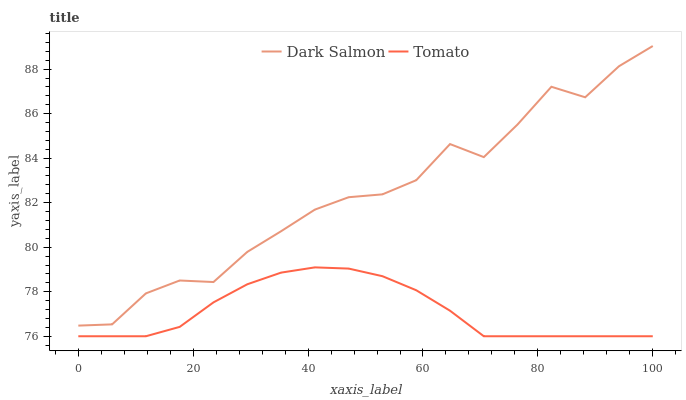Does Tomato have the minimum area under the curve?
Answer yes or no. Yes. Does Dark Salmon have the maximum area under the curve?
Answer yes or no. Yes. Does Dark Salmon have the minimum area under the curve?
Answer yes or no. No. Is Tomato the smoothest?
Answer yes or no. Yes. Is Dark Salmon the roughest?
Answer yes or no. Yes. Is Dark Salmon the smoothest?
Answer yes or no. No. Does Tomato have the lowest value?
Answer yes or no. Yes. Does Dark Salmon have the lowest value?
Answer yes or no. No. Does Dark Salmon have the highest value?
Answer yes or no. Yes. Is Tomato less than Dark Salmon?
Answer yes or no. Yes. Is Dark Salmon greater than Tomato?
Answer yes or no. Yes. Does Tomato intersect Dark Salmon?
Answer yes or no. No. 